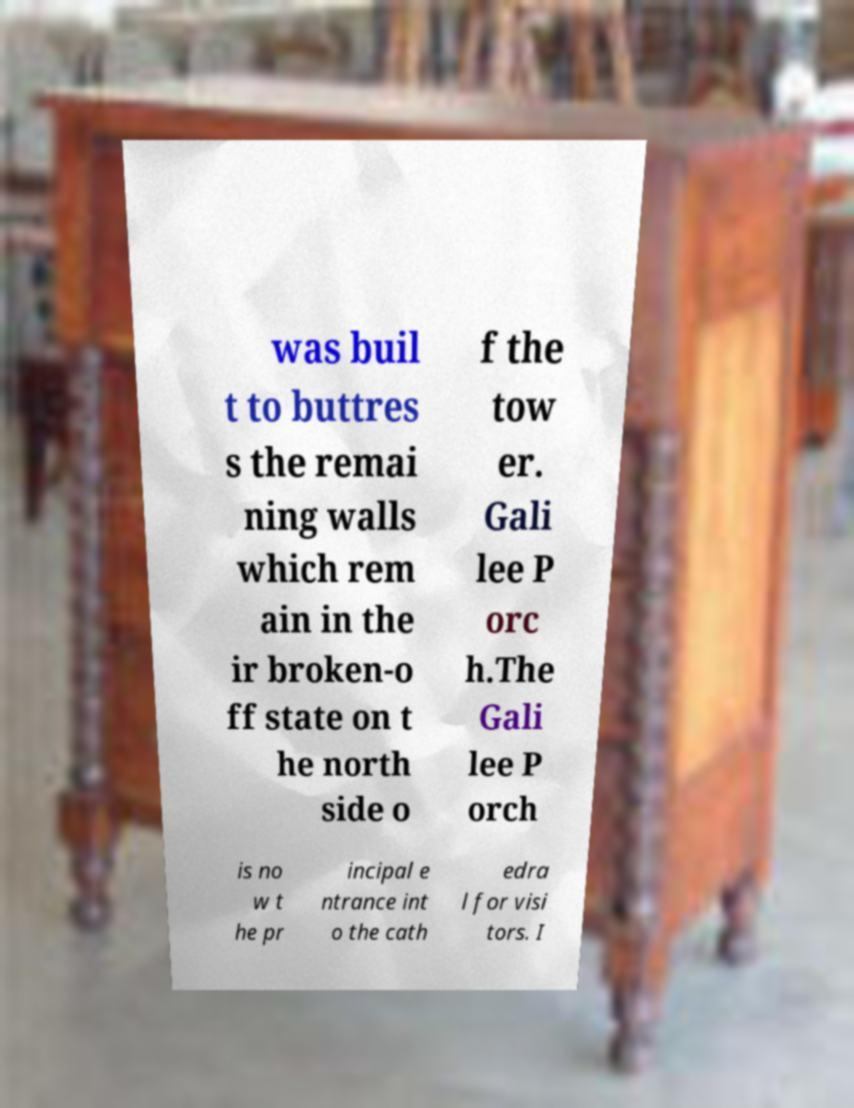Can you accurately transcribe the text from the provided image for me? was buil t to buttres s the remai ning walls which rem ain in the ir broken-o ff state on t he north side o f the tow er. Gali lee P orc h.The Gali lee P orch is no w t he pr incipal e ntrance int o the cath edra l for visi tors. I 